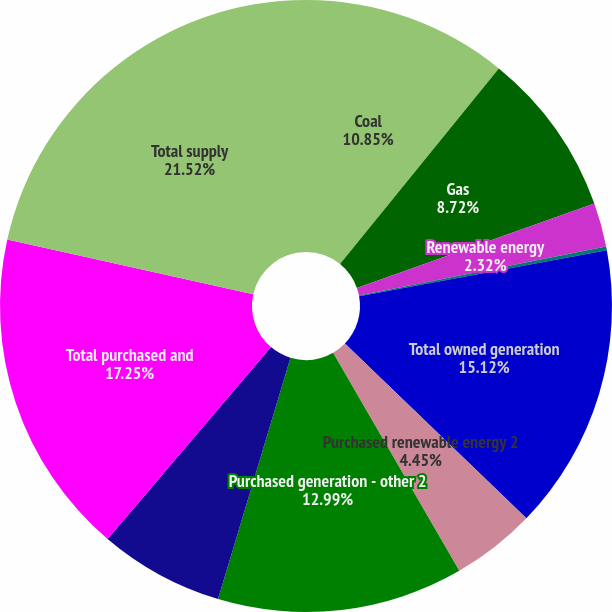<chart> <loc_0><loc_0><loc_500><loc_500><pie_chart><fcel>Coal<fcel>Gas<fcel>Renewable energy<fcel>Net pumped storage 1<fcel>Total owned generation<fcel>Purchased renewable energy 2<fcel>Purchased generation - other 2<fcel>Net interchange power 3<fcel>Total purchased and<fcel>Total supply<nl><fcel>10.85%<fcel>8.72%<fcel>2.32%<fcel>0.19%<fcel>15.12%<fcel>4.45%<fcel>12.99%<fcel>6.59%<fcel>17.25%<fcel>21.52%<nl></chart> 